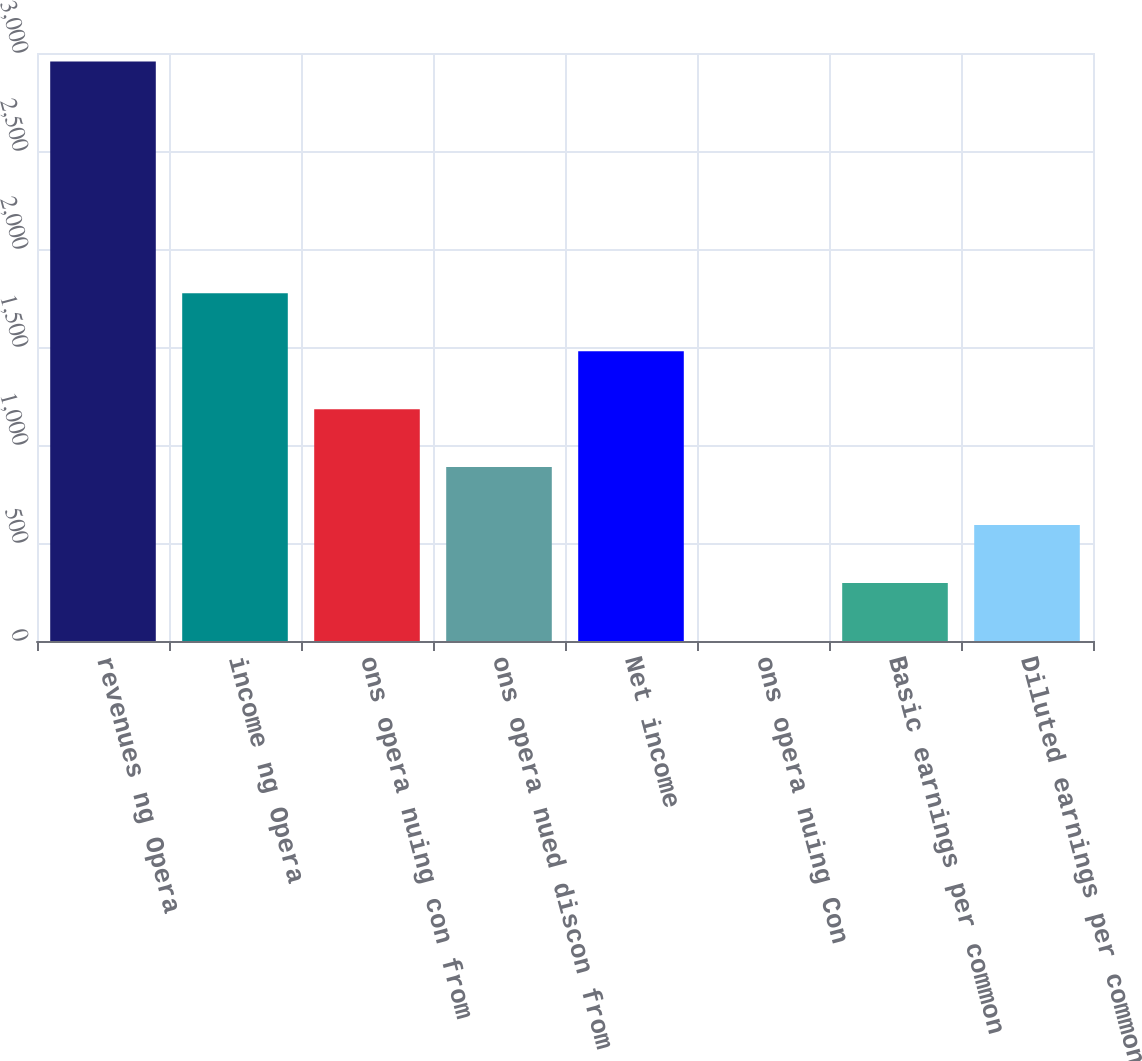Convert chart to OTSL. <chart><loc_0><loc_0><loc_500><loc_500><bar_chart><fcel>revenues ng Opera<fcel>income ng Opera<fcel>ons opera nuing con from<fcel>ons opera nued discon from<fcel>Net income<fcel>ons opera nuing Con<fcel>Basic earnings per common<fcel>Diluted earnings per common<nl><fcel>2956<fcel>1773.81<fcel>1182.73<fcel>887.19<fcel>1478.27<fcel>0.57<fcel>296.11<fcel>591.65<nl></chart> 